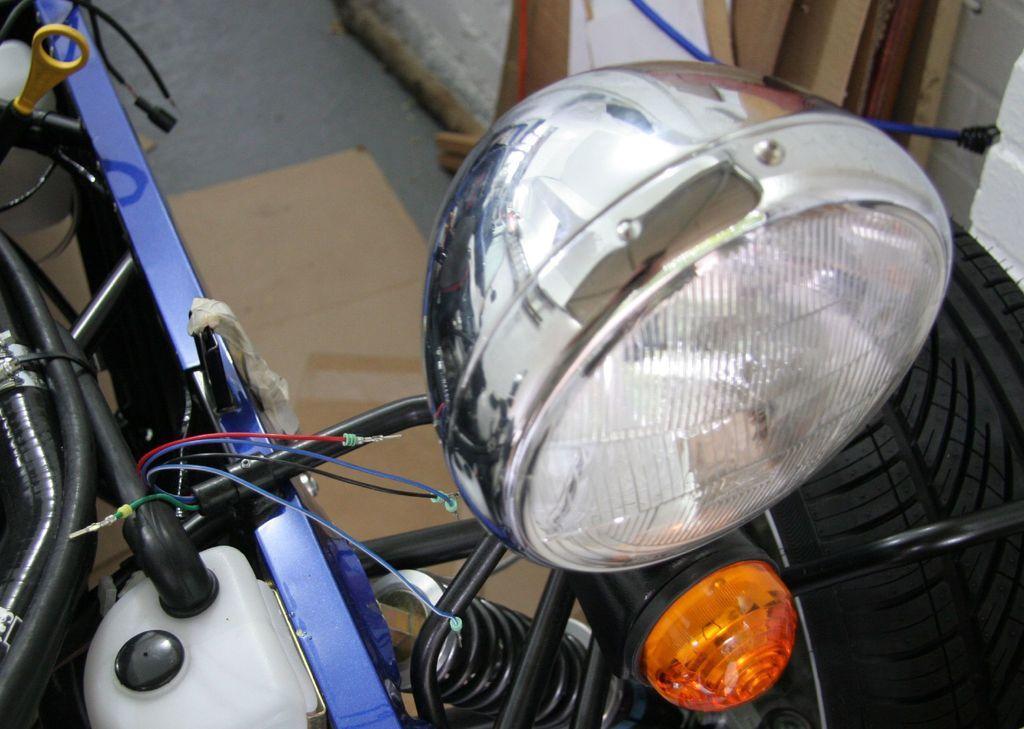Describe this image in one or two sentences. In this image I can see a vehicle. In the background, I can see the wall. 